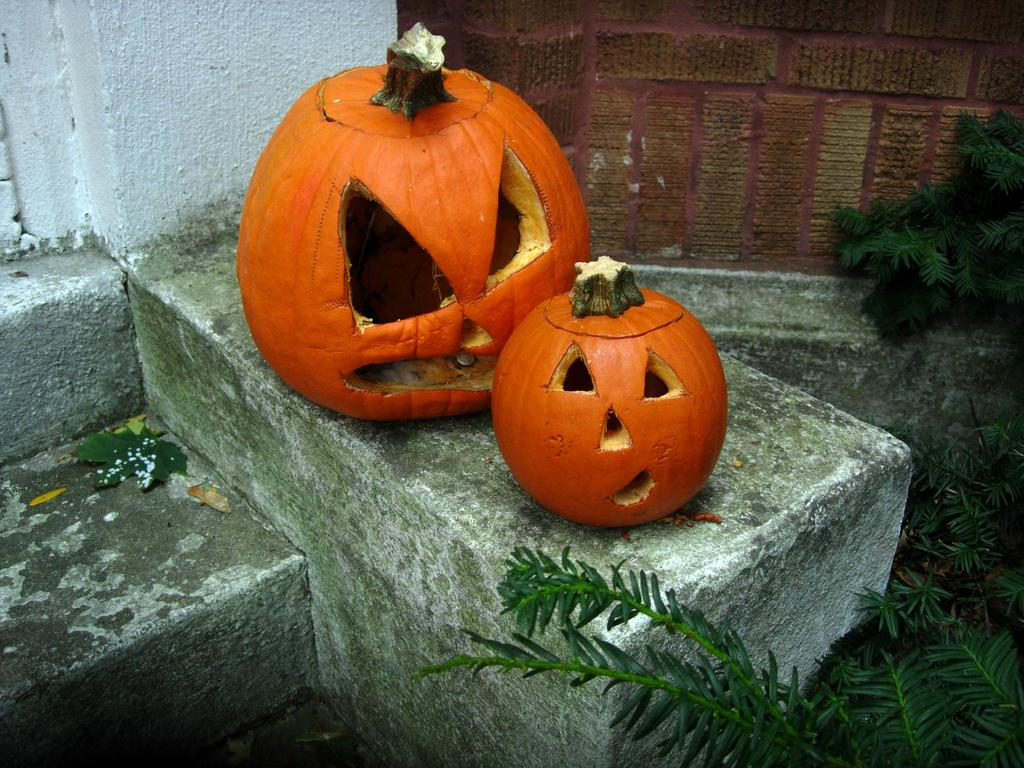How many pumpkins are in the image? There are two pumpkins in the image. What feature do the pumpkins have? The pumpkins have eyes. What can be seen on the left side of the image? There are stairs on the left side of the image. What type of vegetation is on the right side of the image? There are plants on the right side of the image. What type of pig can be seen using a fork in the image? There is no pig or fork present in the image. 